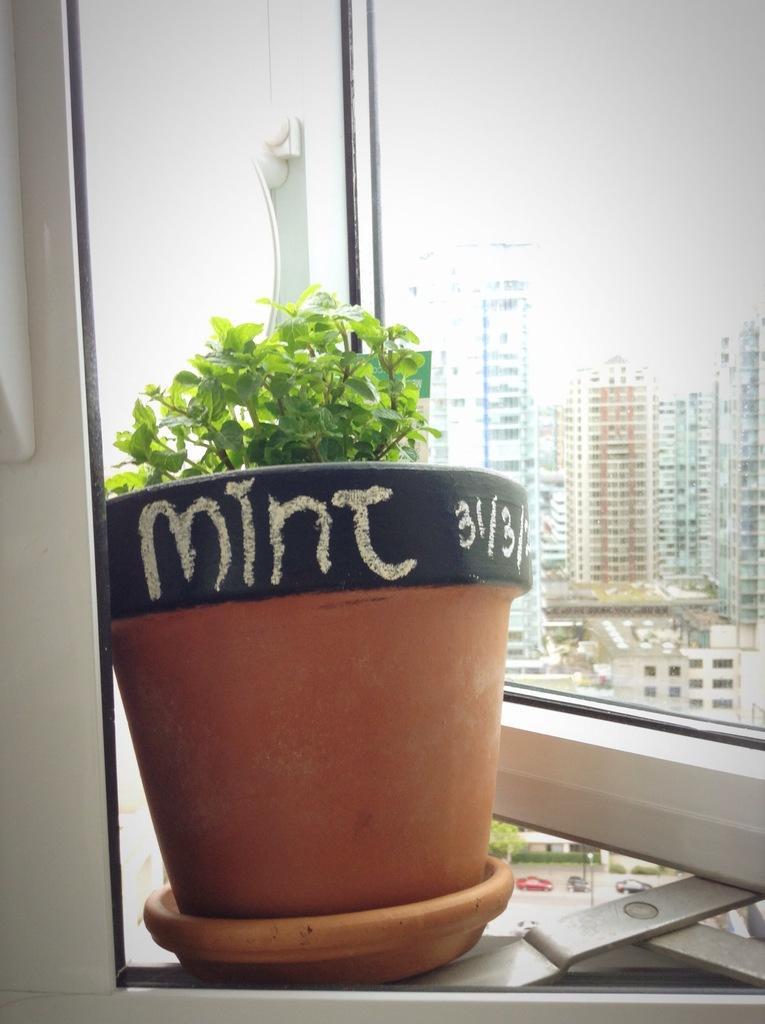In one or two sentences, can you explain what this image depicts? On the left side of the image we can see a flower pot in which a small plant is there. On the right side of the image we can see tall buildings from the window. 